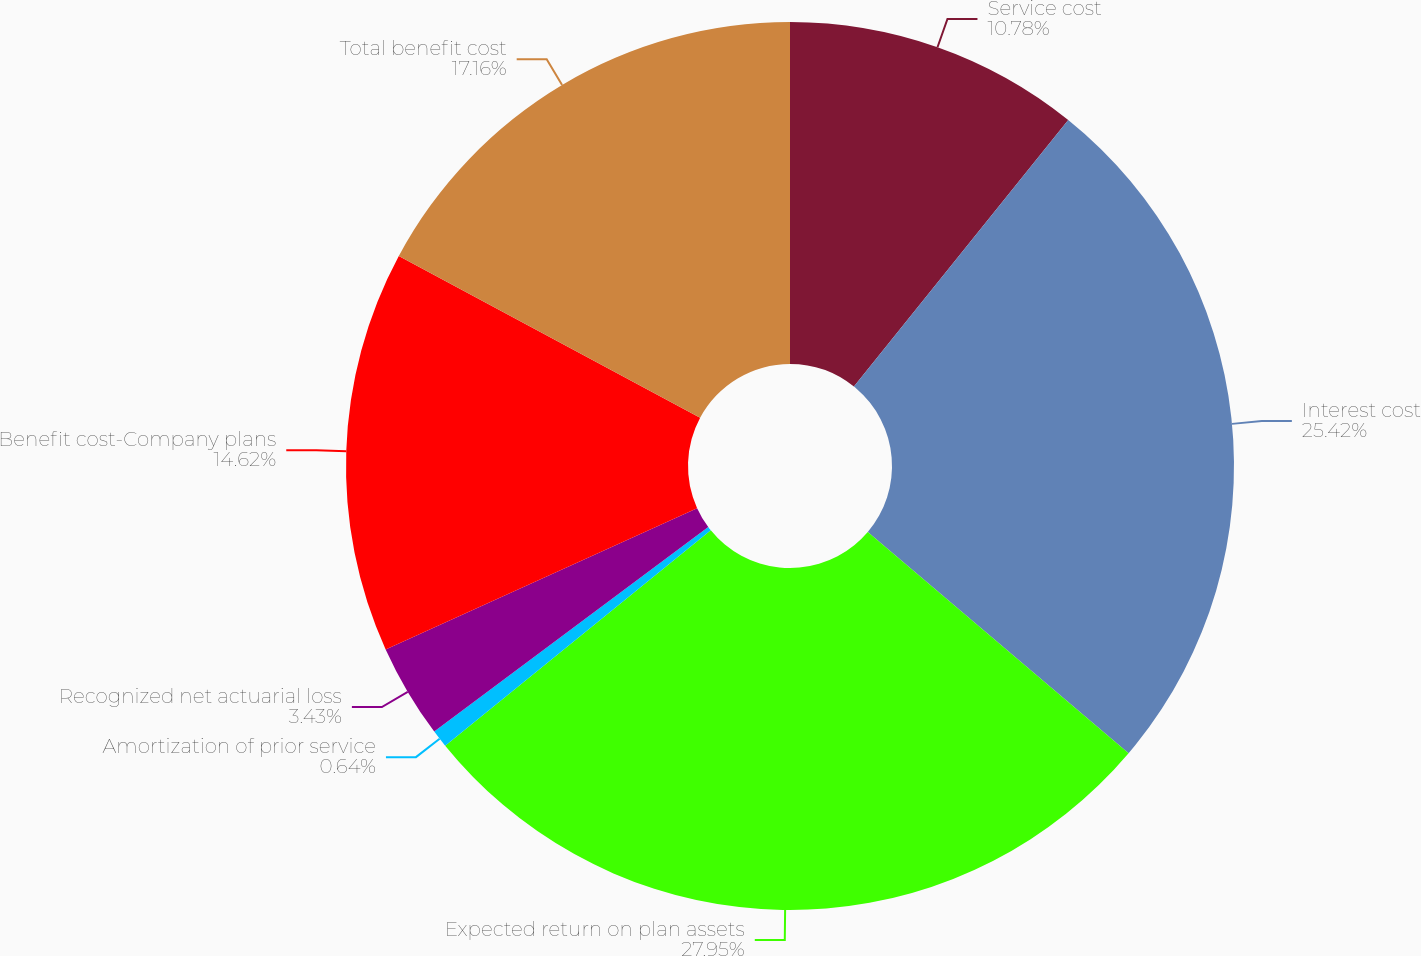Convert chart to OTSL. <chart><loc_0><loc_0><loc_500><loc_500><pie_chart><fcel>Service cost<fcel>Interest cost<fcel>Expected return on plan assets<fcel>Amortization of prior service<fcel>Recognized net actuarial loss<fcel>Benefit cost-Company plans<fcel>Total benefit cost<nl><fcel>10.78%<fcel>25.42%<fcel>27.96%<fcel>0.64%<fcel>3.43%<fcel>14.62%<fcel>17.16%<nl></chart> 